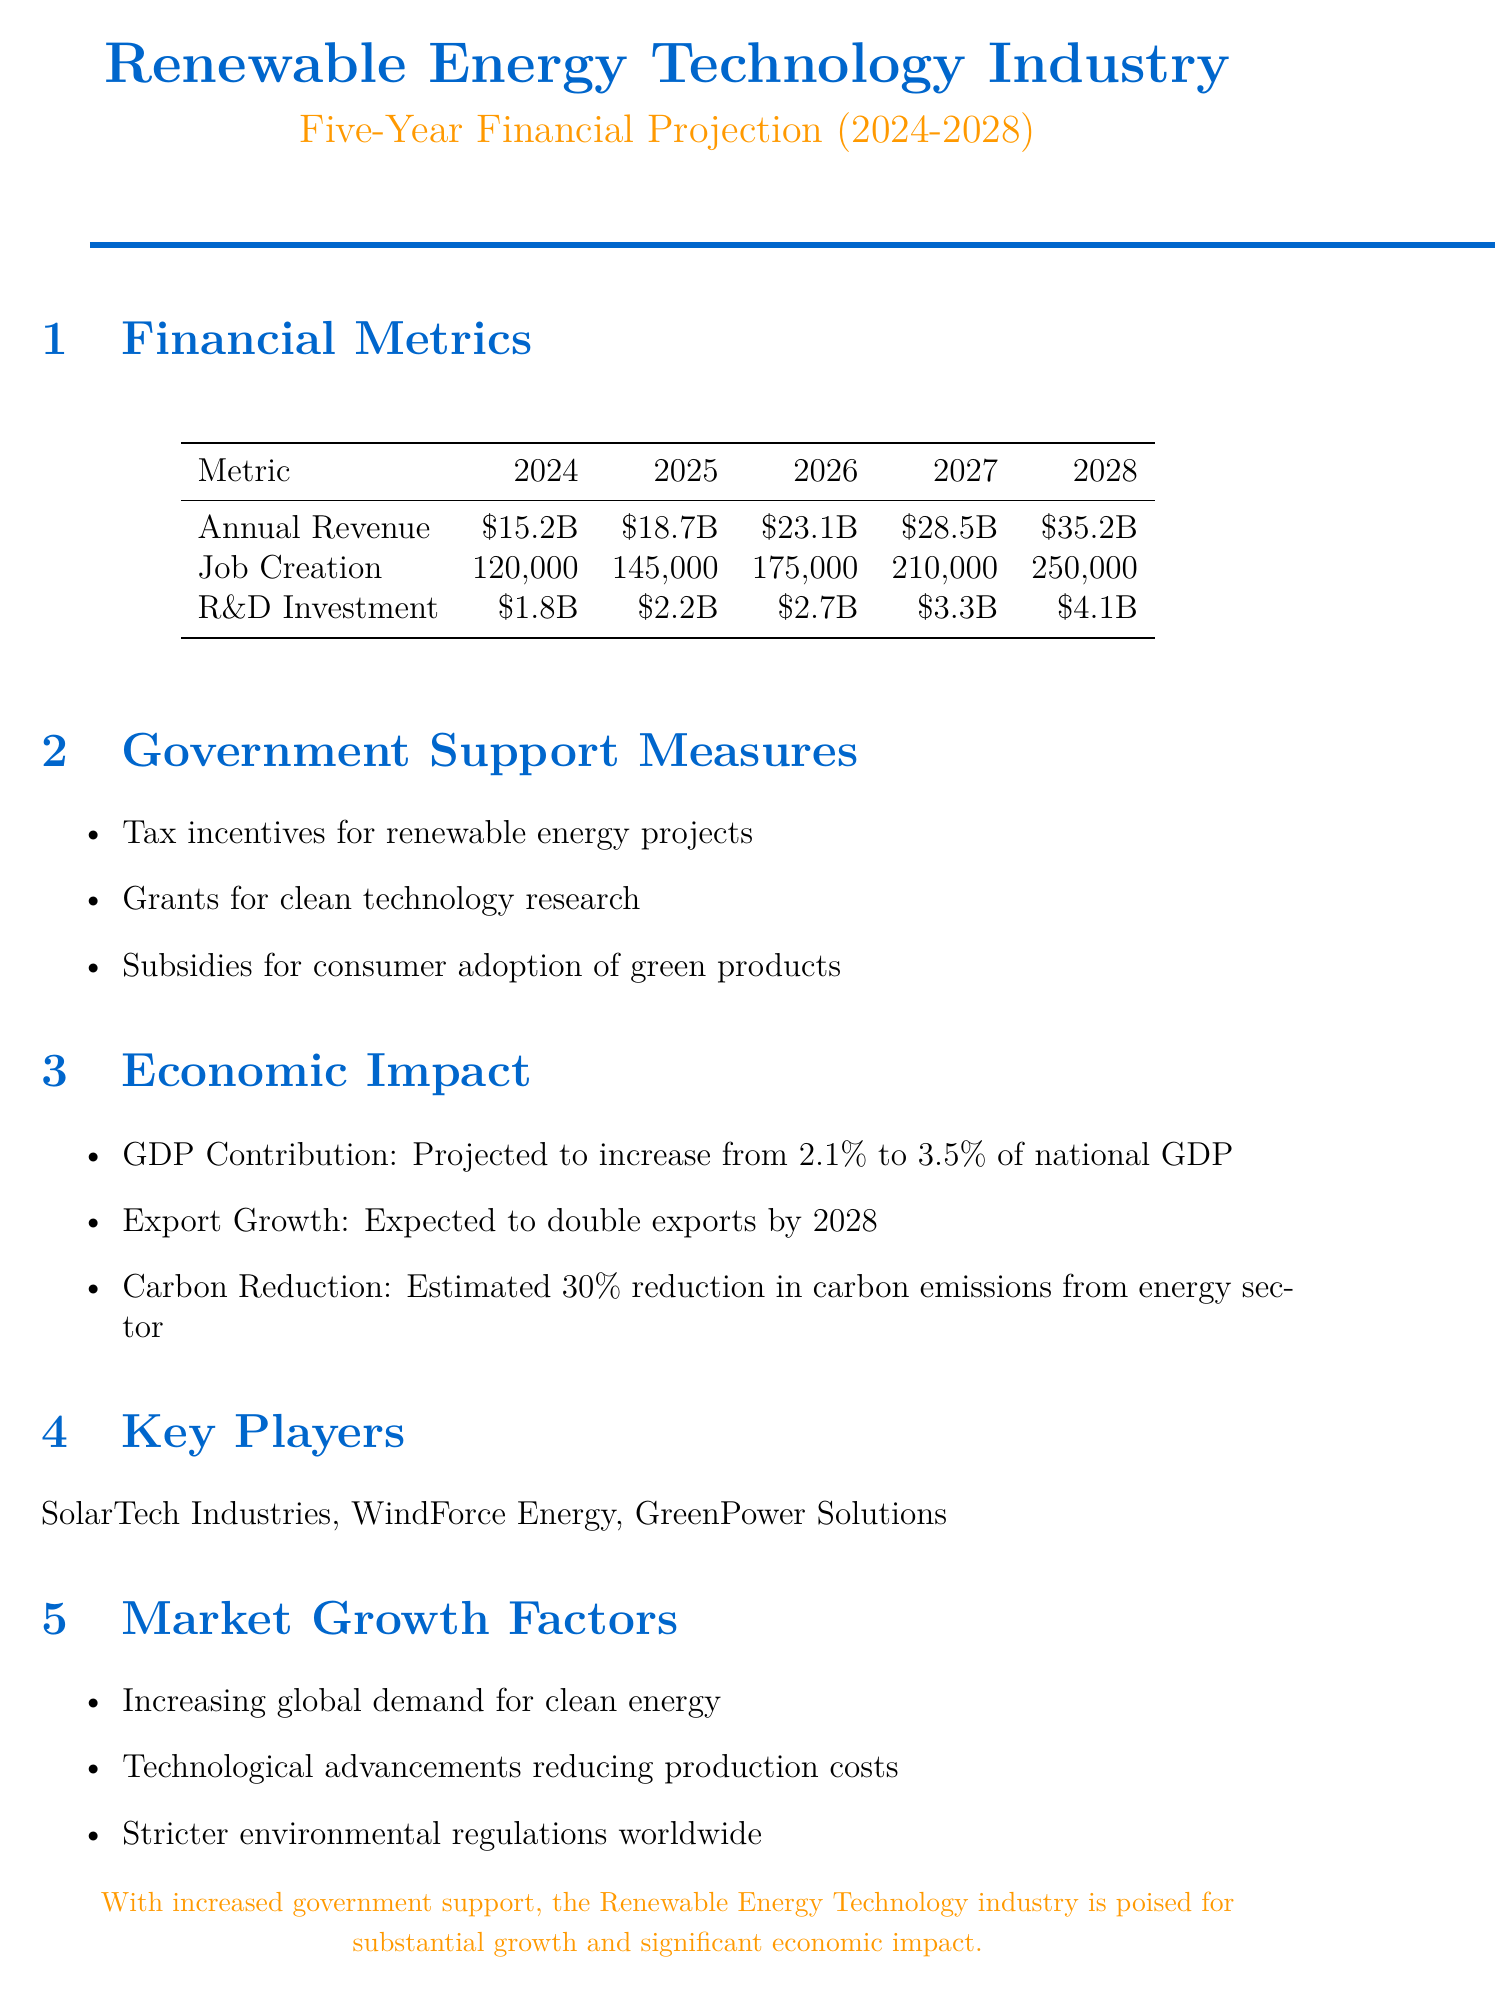What is the annual revenue in 2026? The document provides a specific value for annual revenue in 2026, which is listed in the financial metrics section.
Answer: $23.1 billion How many jobs are projected to be created in 2028? The job creation forecast can be found under the financial metrics, indicating the estimated number of jobs in 2028.
Answer: 250,000 What is the R&D investment in 2024? The document specifies the R&D investment amount for 2024 as part of the financial metrics.
Answer: $1.8 billion What is the projected GDP contribution from this industry by 2028? The economic impact section indicates the expected GDP contribution growth by 2028.
Answer: 3.5% of national GDP Which government support measure involves consumer adoption? The government support measures include various initiatives, one of which focuses on consumer adoption.
Answer: Subsidies for consumer adoption of green products What are the key players in the Renewable Energy Technology industry? The document lists the major companies participating in the industry.
Answer: SolarTech Industries, WindForce Energy, GreenPower Solutions What is one market growth factor mentioned? The document outlines several factors influencing market growth, highlighting the increasing demand for clean energy.
Answer: Increasing global demand for clean energy What is the total job creation between 2024 and 2028? The total job creation can be derived by summing the annual job creation figures from 2024 to 2028 as provided in the document.
Answer: 1,000,000 What is the expected export growth by 2028? The economic impact section mentions the anticipated change in exports specifically by 2028.
Answer: Expected to double exports by 2028 